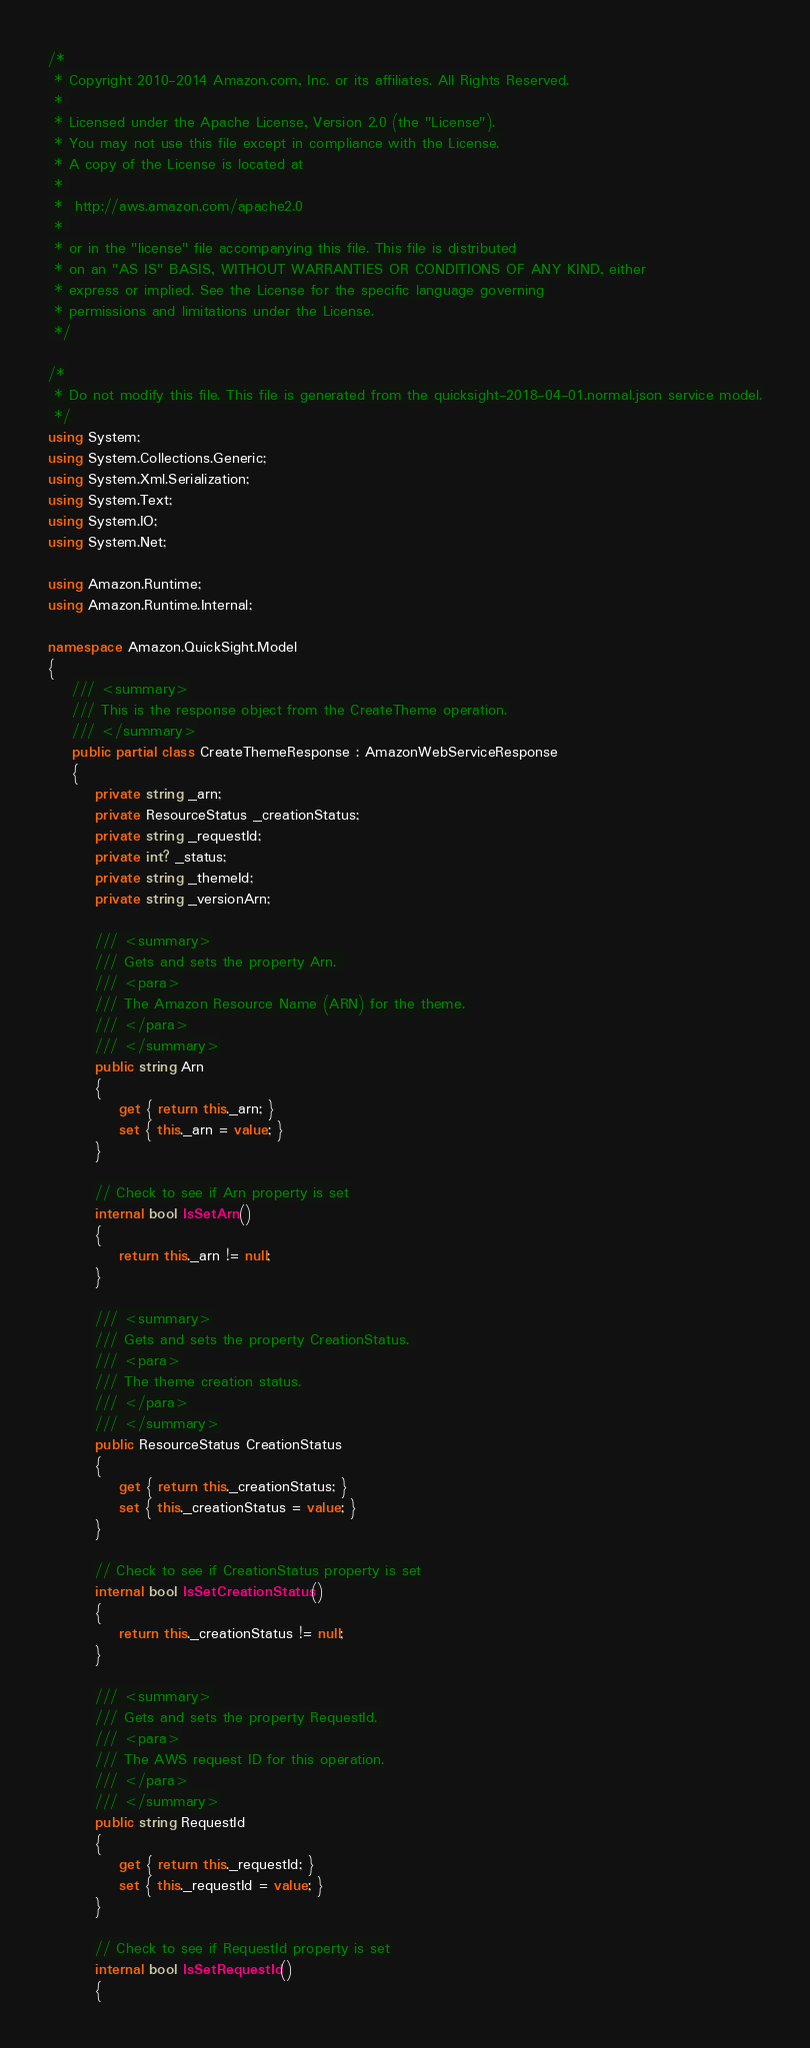<code> <loc_0><loc_0><loc_500><loc_500><_C#_>/*
 * Copyright 2010-2014 Amazon.com, Inc. or its affiliates. All Rights Reserved.
 * 
 * Licensed under the Apache License, Version 2.0 (the "License").
 * You may not use this file except in compliance with the License.
 * A copy of the License is located at
 * 
 *  http://aws.amazon.com/apache2.0
 * 
 * or in the "license" file accompanying this file. This file is distributed
 * on an "AS IS" BASIS, WITHOUT WARRANTIES OR CONDITIONS OF ANY KIND, either
 * express or implied. See the License for the specific language governing
 * permissions and limitations under the License.
 */

/*
 * Do not modify this file. This file is generated from the quicksight-2018-04-01.normal.json service model.
 */
using System;
using System.Collections.Generic;
using System.Xml.Serialization;
using System.Text;
using System.IO;
using System.Net;

using Amazon.Runtime;
using Amazon.Runtime.Internal;

namespace Amazon.QuickSight.Model
{
    /// <summary>
    /// This is the response object from the CreateTheme operation.
    /// </summary>
    public partial class CreateThemeResponse : AmazonWebServiceResponse
    {
        private string _arn;
        private ResourceStatus _creationStatus;
        private string _requestId;
        private int? _status;
        private string _themeId;
        private string _versionArn;

        /// <summary>
        /// Gets and sets the property Arn. 
        /// <para>
        /// The Amazon Resource Name (ARN) for the theme.
        /// </para>
        /// </summary>
        public string Arn
        {
            get { return this._arn; }
            set { this._arn = value; }
        }

        // Check to see if Arn property is set
        internal bool IsSetArn()
        {
            return this._arn != null;
        }

        /// <summary>
        /// Gets and sets the property CreationStatus. 
        /// <para>
        /// The theme creation status.
        /// </para>
        /// </summary>
        public ResourceStatus CreationStatus
        {
            get { return this._creationStatus; }
            set { this._creationStatus = value; }
        }

        // Check to see if CreationStatus property is set
        internal bool IsSetCreationStatus()
        {
            return this._creationStatus != null;
        }

        /// <summary>
        /// Gets and sets the property RequestId. 
        /// <para>
        /// The AWS request ID for this operation.
        /// </para>
        /// </summary>
        public string RequestId
        {
            get { return this._requestId; }
            set { this._requestId = value; }
        }

        // Check to see if RequestId property is set
        internal bool IsSetRequestId()
        {</code> 